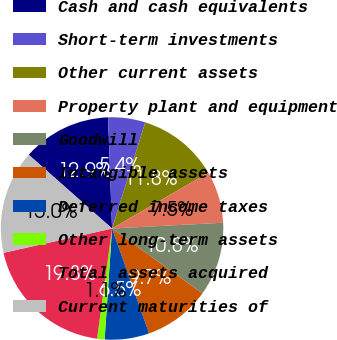<chart> <loc_0><loc_0><loc_500><loc_500><pie_chart><fcel>Cash and cash equivalents<fcel>Short-term investments<fcel>Other current assets<fcel>Property plant and equipment<fcel>Goodwill<fcel>Intangible assets<fcel>Deferred income taxes<fcel>Other long-term assets<fcel>Total assets acquired<fcel>Current maturities of<nl><fcel>12.9%<fcel>5.39%<fcel>11.82%<fcel>7.53%<fcel>10.75%<fcel>9.68%<fcel>6.46%<fcel>1.09%<fcel>19.34%<fcel>15.04%<nl></chart> 